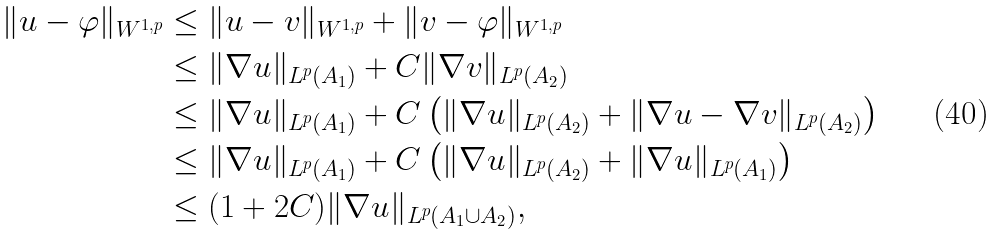<formula> <loc_0><loc_0><loc_500><loc_500>\| u - \varphi \| _ { W ^ { 1 , p } } & \leq \| u - v \| _ { W ^ { 1 , p } } + \| v - \varphi \| _ { W ^ { 1 , p } } \\ & \leq \| \nabla u \| _ { L ^ { p } ( A _ { 1 } ) } + C \| \nabla v \| _ { L ^ { p } ( A _ { 2 } ) } \\ & \leq \| \nabla u \| _ { L ^ { p } ( A _ { 1 } ) } + C \left ( \| \nabla u \| _ { L ^ { p } ( A _ { 2 } ) } + \| \nabla u - \nabla v \| _ { L ^ { p } ( A _ { 2 } ) } \right ) \\ & \leq \| \nabla u \| _ { L ^ { p } ( A _ { 1 } ) } + C \left ( \| \nabla u \| _ { L ^ { p } ( A _ { 2 } ) } + \| \nabla u \| _ { L ^ { p } ( A _ { 1 } ) } \right ) \\ & \leq ( 1 + 2 C ) \| \nabla u \| _ { L ^ { p } ( A _ { 1 } \cup A _ { 2 } ) } ,</formula> 